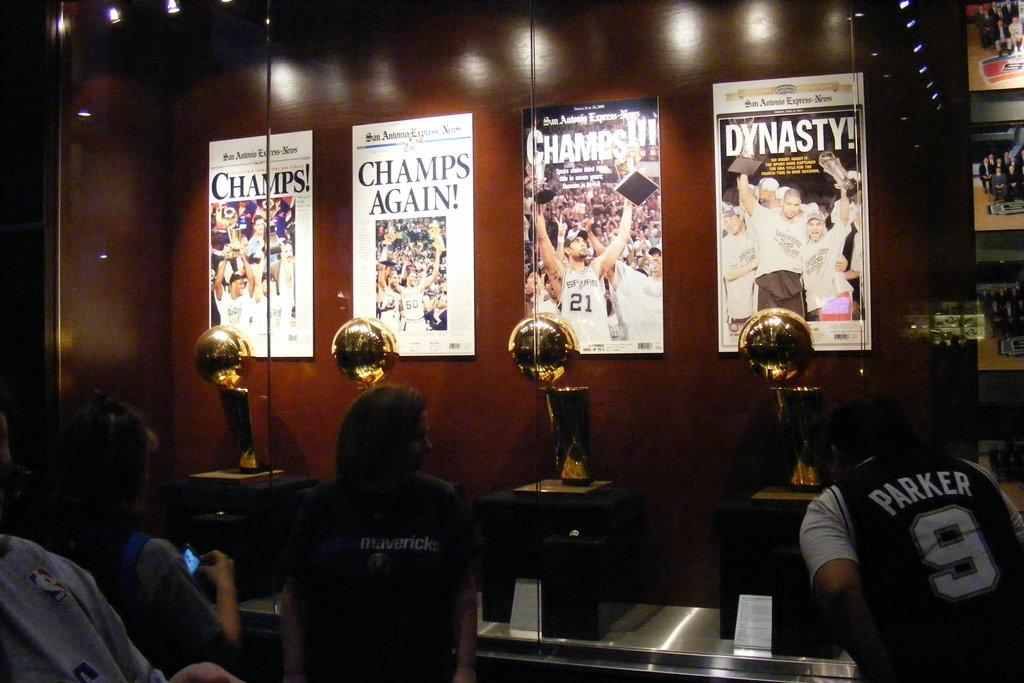<image>
Describe the image concisely. a few posters with one that says Dynasty on it 